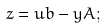Convert formula to latex. <formula><loc_0><loc_0><loc_500><loc_500>z = u b - y A ;</formula> 